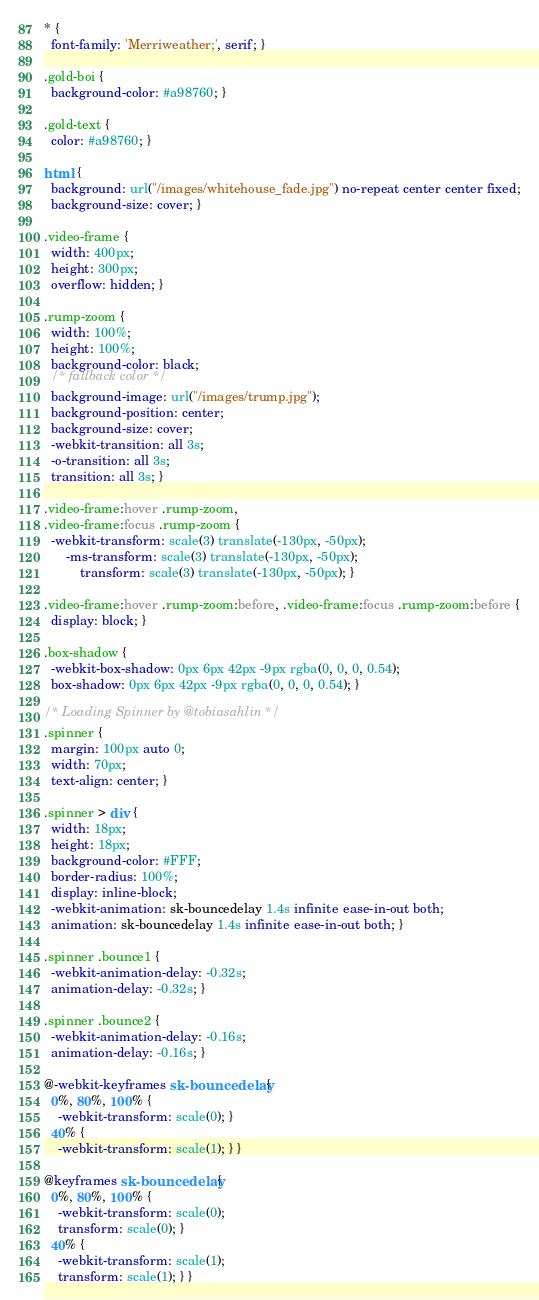Convert code to text. <code><loc_0><loc_0><loc_500><loc_500><_CSS_>* {
  font-family: 'Merriweather;', serif; }

.gold-boi {
  background-color: #a98760; }

.gold-text {
  color: #a98760; }

html {
  background: url("/images/whitehouse_fade.jpg") no-repeat center center fixed;
  background-size: cover; }

.video-frame {
  width: 400px;
  height: 300px;
  overflow: hidden; }

.rump-zoom {
  width: 100%;
  height: 100%;
  background-color: black;
  /* fallback color */
  background-image: url("/images/trump.jpg");
  background-position: center;
  background-size: cover;
  -webkit-transition: all 3s;
  -o-transition: all 3s;
  transition: all 3s; }

.video-frame:hover .rump-zoom,
.video-frame:focus .rump-zoom {
  -webkit-transform: scale(3) translate(-130px, -50px);
      -ms-transform: scale(3) translate(-130px, -50px);
          transform: scale(3) translate(-130px, -50px); }

.video-frame:hover .rump-zoom:before, .video-frame:focus .rump-zoom:before {
  display: block; }

.box-shadow {
  -webkit-box-shadow: 0px 6px 42px -9px rgba(0, 0, 0, 0.54);
  box-shadow: 0px 6px 42px -9px rgba(0, 0, 0, 0.54); }

/* Loading Spinner by @tobiasahlin */
.spinner {
  margin: 100px auto 0;
  width: 70px;
  text-align: center; }

.spinner > div {
  width: 18px;
  height: 18px;
  background-color: #FFF;
  border-radius: 100%;
  display: inline-block;
  -webkit-animation: sk-bouncedelay 1.4s infinite ease-in-out both;
  animation: sk-bouncedelay 1.4s infinite ease-in-out both; }

.spinner .bounce1 {
  -webkit-animation-delay: -0.32s;
  animation-delay: -0.32s; }

.spinner .bounce2 {
  -webkit-animation-delay: -0.16s;
  animation-delay: -0.16s; }

@-webkit-keyframes sk-bouncedelay {
  0%, 80%, 100% {
    -webkit-transform: scale(0); }
  40% {
    -webkit-transform: scale(1); } }

@keyframes sk-bouncedelay {
  0%, 80%, 100% {
    -webkit-transform: scale(0);
    transform: scale(0); }
  40% {
    -webkit-transform: scale(1);
    transform: scale(1); } }
</code> 